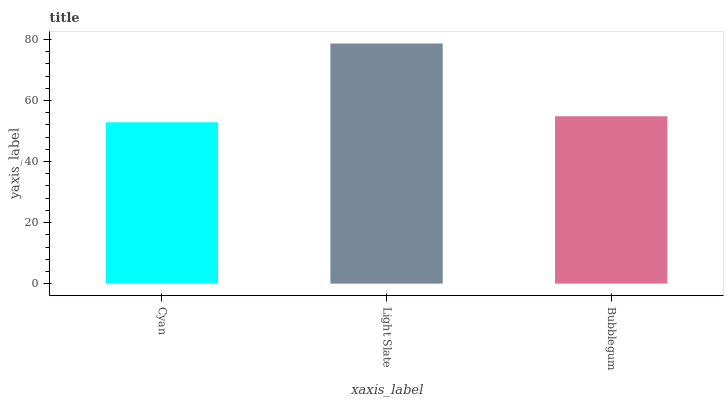Is Cyan the minimum?
Answer yes or no. Yes. Is Light Slate the maximum?
Answer yes or no. Yes. Is Bubblegum the minimum?
Answer yes or no. No. Is Bubblegum the maximum?
Answer yes or no. No. Is Light Slate greater than Bubblegum?
Answer yes or no. Yes. Is Bubblegum less than Light Slate?
Answer yes or no. Yes. Is Bubblegum greater than Light Slate?
Answer yes or no. No. Is Light Slate less than Bubblegum?
Answer yes or no. No. Is Bubblegum the high median?
Answer yes or no. Yes. Is Bubblegum the low median?
Answer yes or no. Yes. Is Light Slate the high median?
Answer yes or no. No. Is Light Slate the low median?
Answer yes or no. No. 